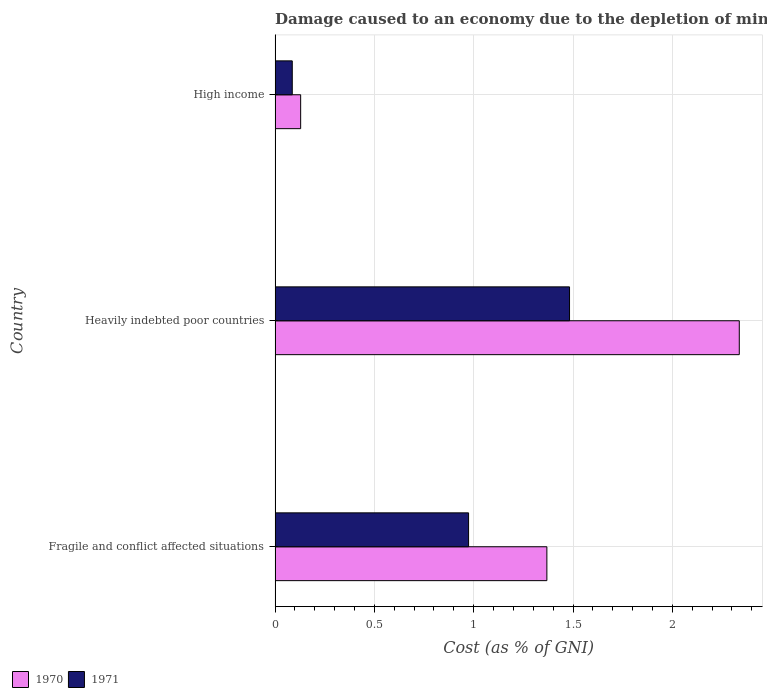How many different coloured bars are there?
Ensure brevity in your answer.  2. Are the number of bars per tick equal to the number of legend labels?
Provide a succinct answer. Yes. How many bars are there on the 3rd tick from the top?
Your response must be concise. 2. How many bars are there on the 1st tick from the bottom?
Offer a terse response. 2. In how many cases, is the number of bars for a given country not equal to the number of legend labels?
Provide a succinct answer. 0. What is the cost of damage caused due to the depletion of minerals in 1970 in Heavily indebted poor countries?
Provide a short and direct response. 2.34. Across all countries, what is the maximum cost of damage caused due to the depletion of minerals in 1971?
Your answer should be very brief. 1.48. Across all countries, what is the minimum cost of damage caused due to the depletion of minerals in 1970?
Your answer should be compact. 0.13. In which country was the cost of damage caused due to the depletion of minerals in 1971 maximum?
Your answer should be compact. Heavily indebted poor countries. In which country was the cost of damage caused due to the depletion of minerals in 1971 minimum?
Ensure brevity in your answer.  High income. What is the total cost of damage caused due to the depletion of minerals in 1970 in the graph?
Offer a very short reply. 3.83. What is the difference between the cost of damage caused due to the depletion of minerals in 1971 in Fragile and conflict affected situations and that in Heavily indebted poor countries?
Provide a short and direct response. -0.51. What is the difference between the cost of damage caused due to the depletion of minerals in 1971 in Heavily indebted poor countries and the cost of damage caused due to the depletion of minerals in 1970 in Fragile and conflict affected situations?
Keep it short and to the point. 0.11. What is the average cost of damage caused due to the depletion of minerals in 1971 per country?
Offer a terse response. 0.85. What is the difference between the cost of damage caused due to the depletion of minerals in 1970 and cost of damage caused due to the depletion of minerals in 1971 in Heavily indebted poor countries?
Offer a very short reply. 0.85. What is the ratio of the cost of damage caused due to the depletion of minerals in 1970 in Fragile and conflict affected situations to that in High income?
Keep it short and to the point. 10.63. What is the difference between the highest and the second highest cost of damage caused due to the depletion of minerals in 1971?
Offer a very short reply. 0.51. What is the difference between the highest and the lowest cost of damage caused due to the depletion of minerals in 1971?
Offer a terse response. 1.4. What does the 1st bar from the bottom in Fragile and conflict affected situations represents?
Your answer should be very brief. 1970. Are the values on the major ticks of X-axis written in scientific E-notation?
Your answer should be compact. No. Where does the legend appear in the graph?
Provide a succinct answer. Bottom left. How are the legend labels stacked?
Make the answer very short. Horizontal. What is the title of the graph?
Offer a very short reply. Damage caused to an economy due to the depletion of minerals. What is the label or title of the X-axis?
Offer a very short reply. Cost (as % of GNI). What is the label or title of the Y-axis?
Your answer should be very brief. Country. What is the Cost (as % of GNI) of 1970 in Fragile and conflict affected situations?
Keep it short and to the point. 1.37. What is the Cost (as % of GNI) in 1971 in Fragile and conflict affected situations?
Offer a terse response. 0.97. What is the Cost (as % of GNI) in 1970 in Heavily indebted poor countries?
Ensure brevity in your answer.  2.34. What is the Cost (as % of GNI) of 1971 in Heavily indebted poor countries?
Your answer should be compact. 1.48. What is the Cost (as % of GNI) in 1970 in High income?
Make the answer very short. 0.13. What is the Cost (as % of GNI) of 1971 in High income?
Ensure brevity in your answer.  0.09. Across all countries, what is the maximum Cost (as % of GNI) of 1970?
Your response must be concise. 2.34. Across all countries, what is the maximum Cost (as % of GNI) of 1971?
Your answer should be compact. 1.48. Across all countries, what is the minimum Cost (as % of GNI) of 1970?
Ensure brevity in your answer.  0.13. Across all countries, what is the minimum Cost (as % of GNI) in 1971?
Ensure brevity in your answer.  0.09. What is the total Cost (as % of GNI) of 1970 in the graph?
Your answer should be very brief. 3.83. What is the total Cost (as % of GNI) in 1971 in the graph?
Your answer should be compact. 2.54. What is the difference between the Cost (as % of GNI) of 1970 in Fragile and conflict affected situations and that in Heavily indebted poor countries?
Keep it short and to the point. -0.97. What is the difference between the Cost (as % of GNI) of 1971 in Fragile and conflict affected situations and that in Heavily indebted poor countries?
Keep it short and to the point. -0.51. What is the difference between the Cost (as % of GNI) in 1970 in Fragile and conflict affected situations and that in High income?
Provide a succinct answer. 1.24. What is the difference between the Cost (as % of GNI) in 1971 in Fragile and conflict affected situations and that in High income?
Make the answer very short. 0.89. What is the difference between the Cost (as % of GNI) in 1970 in Heavily indebted poor countries and that in High income?
Your response must be concise. 2.21. What is the difference between the Cost (as % of GNI) in 1971 in Heavily indebted poor countries and that in High income?
Your response must be concise. 1.4. What is the difference between the Cost (as % of GNI) in 1970 in Fragile and conflict affected situations and the Cost (as % of GNI) in 1971 in Heavily indebted poor countries?
Your response must be concise. -0.11. What is the difference between the Cost (as % of GNI) in 1970 in Fragile and conflict affected situations and the Cost (as % of GNI) in 1971 in High income?
Your answer should be compact. 1.28. What is the difference between the Cost (as % of GNI) in 1970 in Heavily indebted poor countries and the Cost (as % of GNI) in 1971 in High income?
Make the answer very short. 2.25. What is the average Cost (as % of GNI) in 1970 per country?
Offer a very short reply. 1.28. What is the average Cost (as % of GNI) in 1971 per country?
Make the answer very short. 0.85. What is the difference between the Cost (as % of GNI) of 1970 and Cost (as % of GNI) of 1971 in Fragile and conflict affected situations?
Keep it short and to the point. 0.39. What is the difference between the Cost (as % of GNI) of 1970 and Cost (as % of GNI) of 1971 in Heavily indebted poor countries?
Provide a short and direct response. 0.85. What is the difference between the Cost (as % of GNI) in 1970 and Cost (as % of GNI) in 1971 in High income?
Provide a short and direct response. 0.04. What is the ratio of the Cost (as % of GNI) of 1970 in Fragile and conflict affected situations to that in Heavily indebted poor countries?
Offer a terse response. 0.59. What is the ratio of the Cost (as % of GNI) of 1971 in Fragile and conflict affected situations to that in Heavily indebted poor countries?
Your answer should be compact. 0.66. What is the ratio of the Cost (as % of GNI) in 1970 in Fragile and conflict affected situations to that in High income?
Offer a very short reply. 10.63. What is the ratio of the Cost (as % of GNI) in 1971 in Fragile and conflict affected situations to that in High income?
Provide a succinct answer. 11.26. What is the ratio of the Cost (as % of GNI) of 1970 in Heavily indebted poor countries to that in High income?
Provide a short and direct response. 18.15. What is the ratio of the Cost (as % of GNI) in 1971 in Heavily indebted poor countries to that in High income?
Give a very brief answer. 17.13. What is the difference between the highest and the second highest Cost (as % of GNI) in 1970?
Your answer should be very brief. 0.97. What is the difference between the highest and the second highest Cost (as % of GNI) of 1971?
Offer a very short reply. 0.51. What is the difference between the highest and the lowest Cost (as % of GNI) of 1970?
Keep it short and to the point. 2.21. What is the difference between the highest and the lowest Cost (as % of GNI) of 1971?
Give a very brief answer. 1.4. 